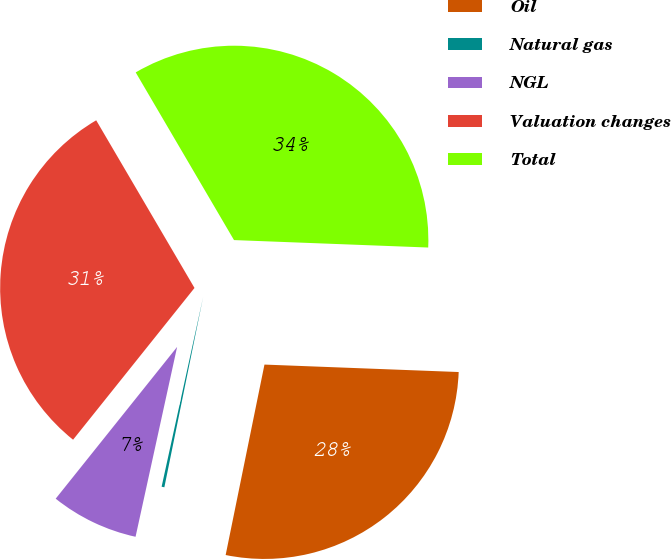Convert chart. <chart><loc_0><loc_0><loc_500><loc_500><pie_chart><fcel>Oil<fcel>Natural gas<fcel>NGL<fcel>Valuation changes<fcel>Total<nl><fcel>27.59%<fcel>0.23%<fcel>7.31%<fcel>30.82%<fcel>34.05%<nl></chart> 